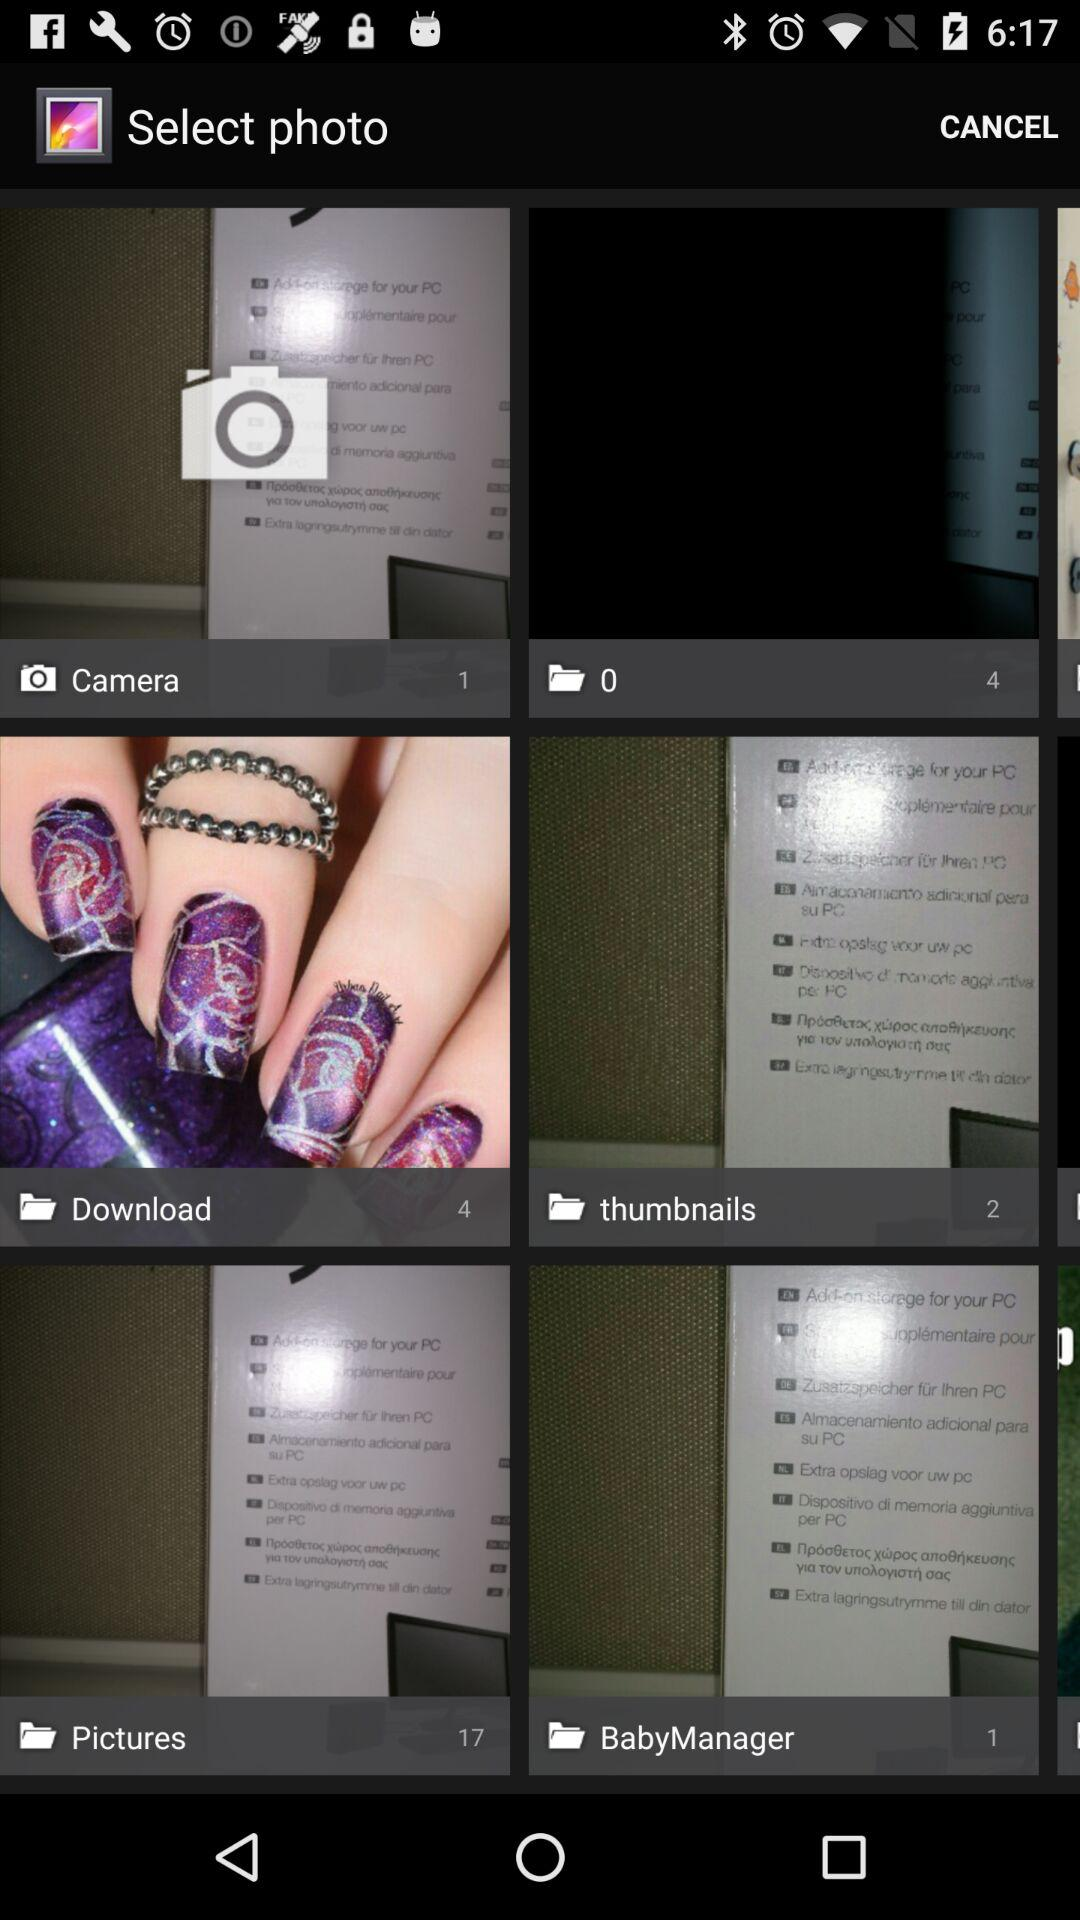Which folder has 17 photos? There are 17 photos in "Pictures" folder. 